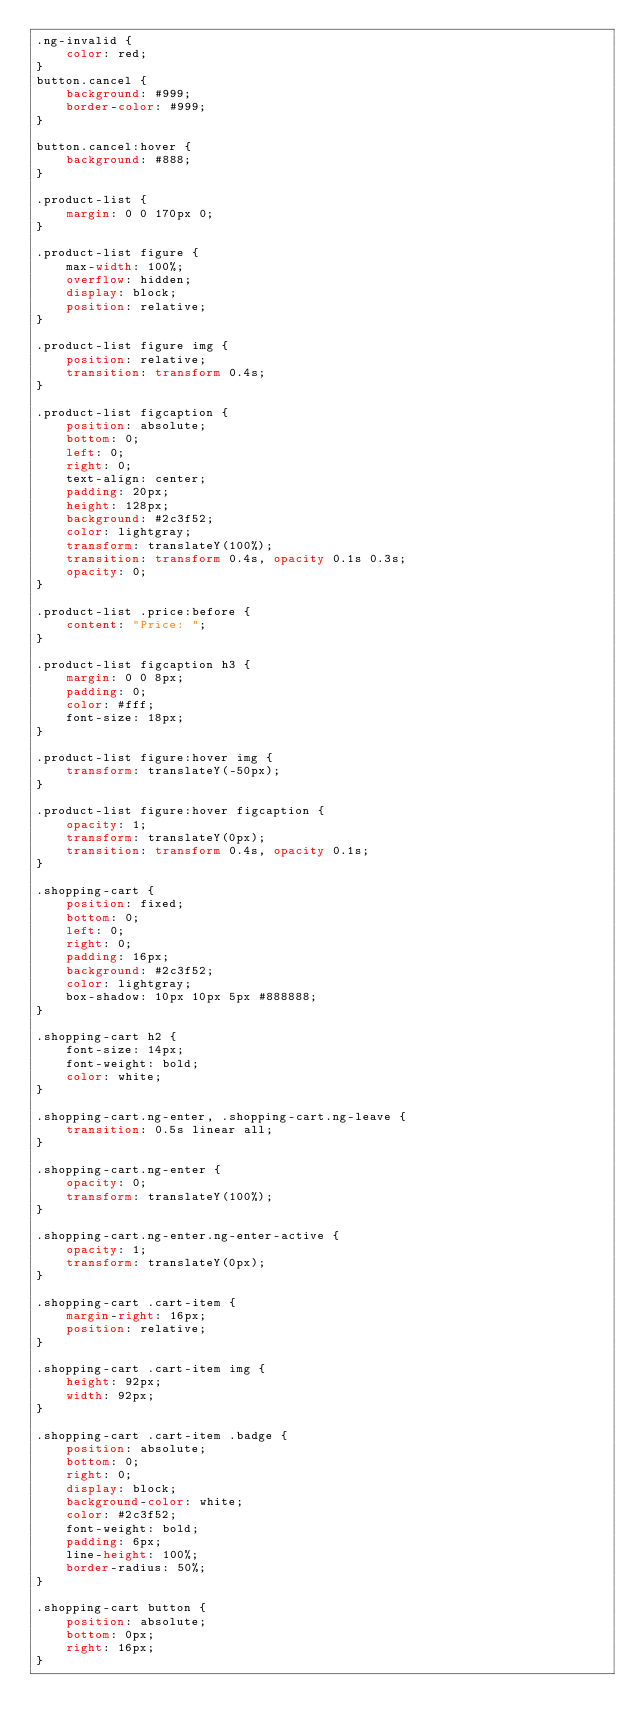Convert code to text. <code><loc_0><loc_0><loc_500><loc_500><_CSS_>.ng-invalid {
    color: red;
}
button.cancel {
	background: #999;
	border-color: #999;
}

button.cancel:hover {
	background: #888;
}

.product-list {
	margin: 0 0 170px 0;
}

.product-list figure {
	max-width: 100%;
	overflow: hidden;
	display: block;
	position: relative;
}

.product-list figure img {
	position: relative;
	transition: transform 0.4s;
}

.product-list figcaption {
	position: absolute;
	bottom: 0;
	left: 0;
	right: 0;
	text-align: center;
	padding: 20px;
	height: 128px;
	background: #2c3f52;
	color: lightgray;
	transform: translateY(100%);
	transition: transform 0.4s, opacity 0.1s 0.3s;
	opacity: 0;
}

.product-list .price:before {
	content: "Price: ";
}

.product-list figcaption h3 {
	margin: 0 0 8px;
	padding: 0;
	color: #fff;
	font-size: 18px;
}

.product-list figure:hover img {
	transform: translateY(-50px);
}

.product-list figure:hover figcaption {
	opacity: 1;
	transform: translateY(0px);
	transition: transform 0.4s, opacity 0.1s;
}

.shopping-cart {
	position: fixed;
	bottom: 0;
	left: 0;
	right: 0;
	padding: 16px;
	background: #2c3f52;
	color: lightgray;
	box-shadow: 10px 10px 5px #888888;
}

.shopping-cart h2 {
	font-size: 14px;
	font-weight: bold;
	color: white;
}

.shopping-cart.ng-enter, .shopping-cart.ng-leave {
	transition: 0.5s linear all;
}

.shopping-cart.ng-enter {
	opacity: 0;
	transform: translateY(100%);
}

.shopping-cart.ng-enter.ng-enter-active {
	opacity: 1;
	transform: translateY(0px);
}

.shopping-cart .cart-item {
	margin-right: 16px;
	position: relative;
}

.shopping-cart .cart-item img {
	height: 92px;
	width: 92px;
}

.shopping-cart .cart-item .badge {
	position: absolute;
	bottom: 0;
	right: 0;
	display: block;
	background-color: white;
	color: #2c3f52;
	font-weight: bold;
	padding: 6px;
	line-height: 100%;
	border-radius: 50%;
}

.shopping-cart button {
	position: absolute;
	bottom: 0px;
	right: 16px;
}

</code> 